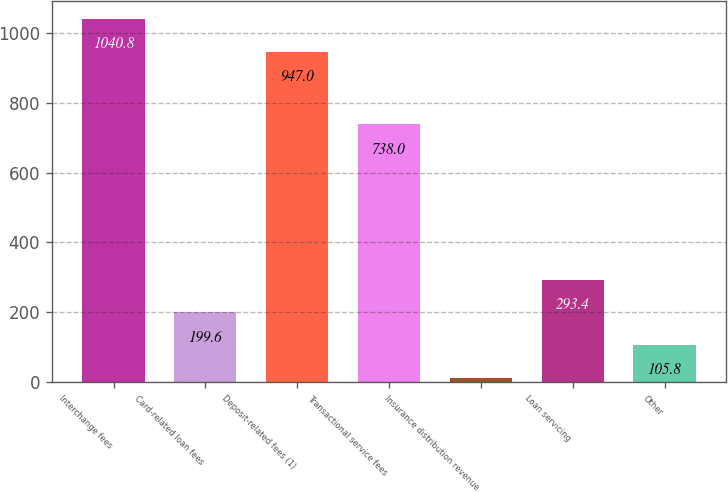Convert chart. <chart><loc_0><loc_0><loc_500><loc_500><bar_chart><fcel>Interchange fees<fcel>Card-related loan fees<fcel>Deposit-related fees (1)<fcel>Transactional service fees<fcel>Insurance distribution revenue<fcel>Loan servicing<fcel>Other<nl><fcel>1040.8<fcel>199.6<fcel>947<fcel>738<fcel>12<fcel>293.4<fcel>105.8<nl></chart> 